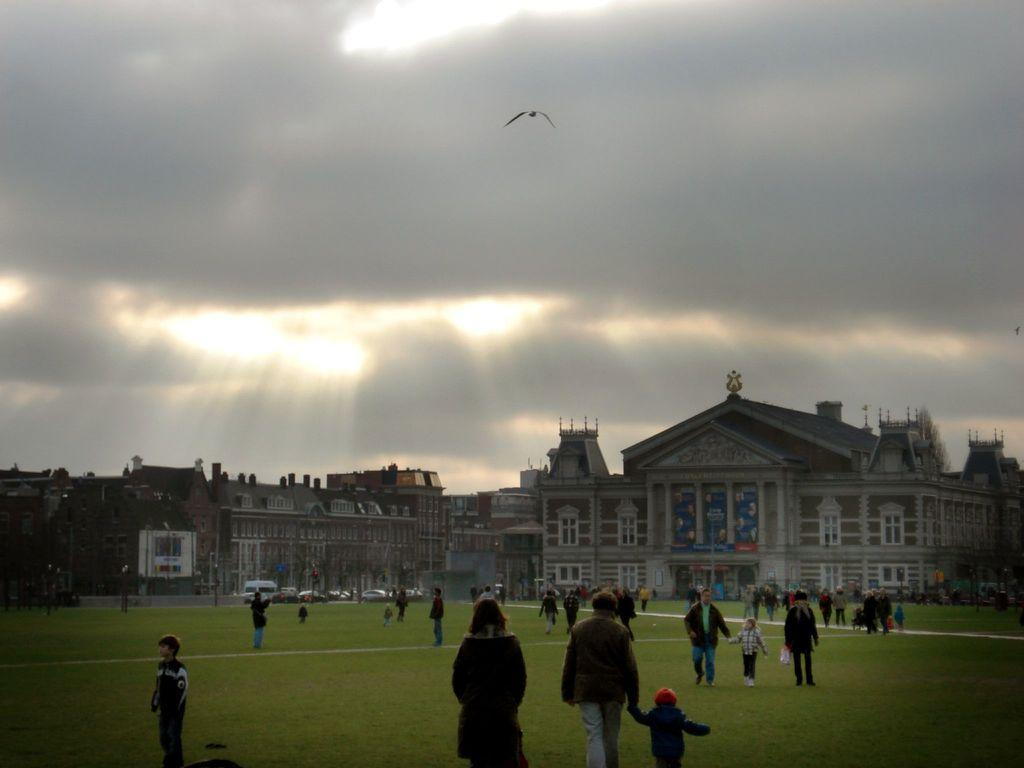What type of structures can be seen in the image? There are buildings in the image. What else is present on the ground in the image? There are persons on the ground in the image. What type of animal is visible in the image? There is a bird in the image. What is visible in the background of the image? The sky is visible in the image, and there are clouds in the sky. How many beads are being used by the persons in the image? There is no mention of beads in the image; the focus is on buildings, persons, a bird, and the sky. What idea is being discussed by the persons in the image? There is no information about a discussion or an idea being shared among the persons in the image. 